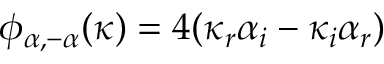Convert formula to latex. <formula><loc_0><loc_0><loc_500><loc_500>\phi _ { \alpha , - \alpha } ( \kappa ) = 4 ( \kappa _ { r } \alpha _ { i } - \kappa _ { i } \alpha _ { r } )</formula> 